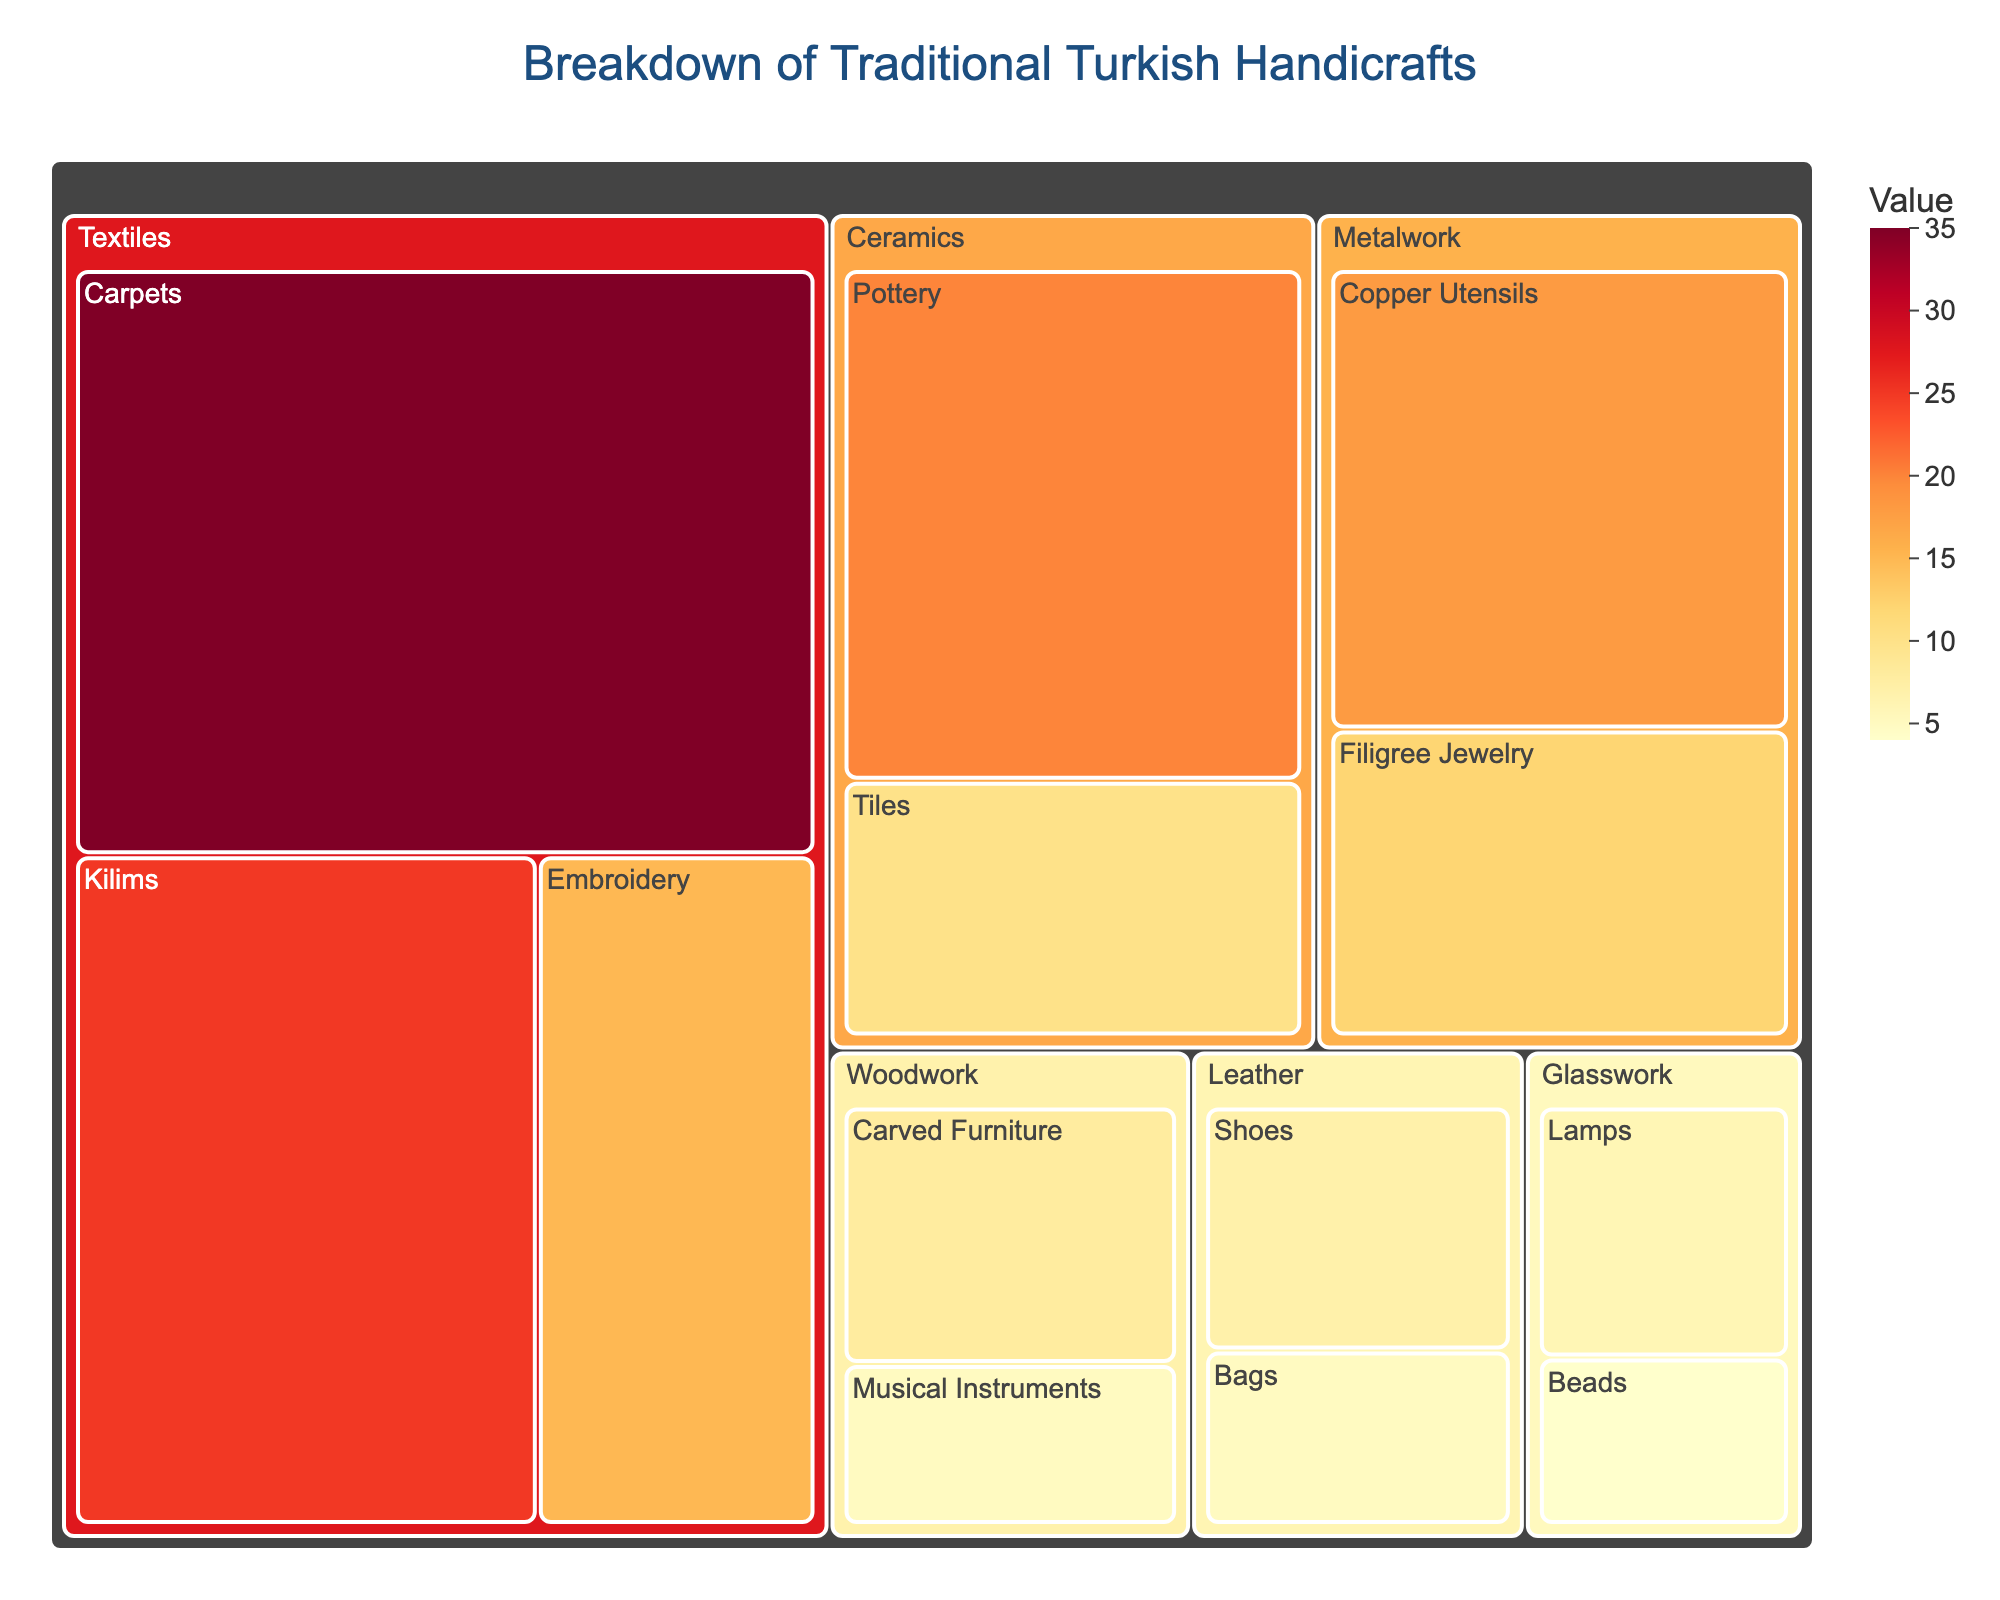What's the title of the treemap? Look at the top center of the treemap where the title is displayed.
Answer: Breakdown of Traditional Turkish Handicrafts What category has the largest value? Observe the sections of the treemap and note the category with the largest combined area.
Answer: Textiles Which subcategory of Metalwork has a higher value? Compare the areas of the subcategories under Metalwork.
Answer: Copper Utensils What total value do the Leather subcategories sum to? Sum the values of Shoes and Bags in the Leather category.
Answer: 12 Which has a greater value: Kilims in Textiles or Pottery in Ceramics? Compare the values of Kilims (25) and Pottery (20).
Answer: Kilims What is the smallest subcategory in the chart? Look for the subcategory with the smallest area in the treemap.
Answer: Beads How many categories are there in total? Count the distinct main categories displayed in the treemap.
Answer: 6 Which category has the smallest total value? Find the category with the smallest combined area by summing their subcategories' values.
Answer: Glasswork What is the combined value of all subcategories in the Textiles category? Sum the values of Carpets, Kilims, and Embroidery.
Answer: 75 What's the difference between the value of Carpets and Embroidery? Subtract the value of Embroidery (15) from Carpets (35).
Answer: 20 